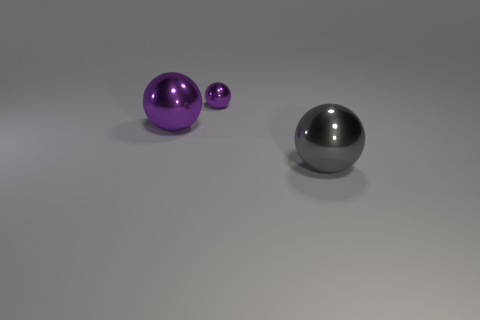What shape is the metallic object that is both to the left of the big gray metallic sphere and in front of the small purple metal sphere?
Provide a short and direct response. Sphere. There is another gray object that is the same material as the tiny thing; what size is it?
Keep it short and to the point. Large. There is a small object; is it the same color as the large object left of the big gray shiny thing?
Keep it short and to the point. Yes. The sphere that is both in front of the small purple thing and behind the large gray thing is made of what material?
Ensure brevity in your answer.  Metal. The other metallic thing that is the same color as the small object is what size?
Provide a succinct answer. Large. Do the purple object that is in front of the small object and the shiny thing that is right of the tiny purple metallic object have the same shape?
Ensure brevity in your answer.  Yes. Is there a tiny purple ball?
Offer a very short reply. Yes. What color is the other big shiny thing that is the same shape as the gray object?
Make the answer very short. Purple. There is another metal object that is the same size as the gray object; what color is it?
Keep it short and to the point. Purple. Do the large gray object and the small thing have the same material?
Offer a very short reply. Yes. 